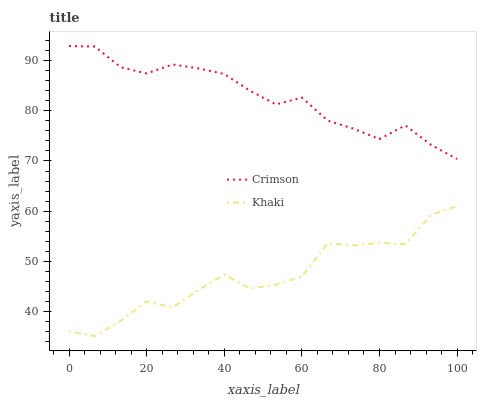Does Khaki have the minimum area under the curve?
Answer yes or no. Yes. Does Crimson have the maximum area under the curve?
Answer yes or no. Yes. Does Khaki have the maximum area under the curve?
Answer yes or no. No. Is Crimson the smoothest?
Answer yes or no. Yes. Is Khaki the roughest?
Answer yes or no. Yes. Is Khaki the smoothest?
Answer yes or no. No. Does Khaki have the highest value?
Answer yes or no. No. Is Khaki less than Crimson?
Answer yes or no. Yes. Is Crimson greater than Khaki?
Answer yes or no. Yes. Does Khaki intersect Crimson?
Answer yes or no. No. 